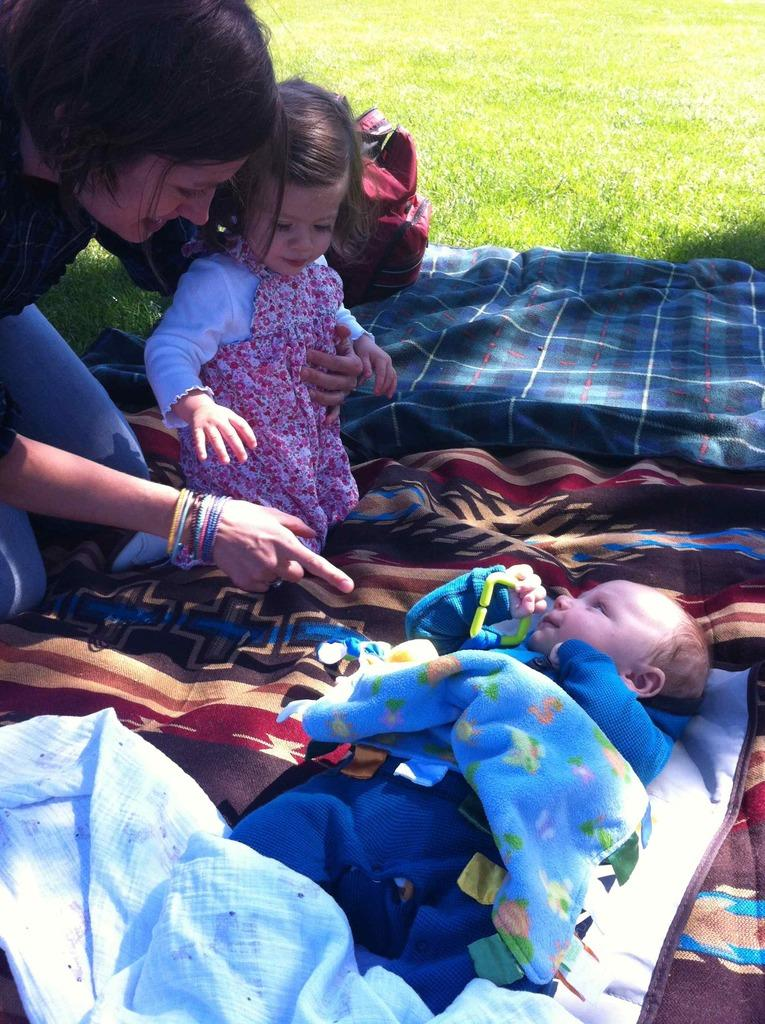What is the baby doing in the image? The baby is lying on a blanket in the image. Who else is present in the image besides the baby? There is a woman and a small girl in the image. How is the small girl positioned in relation to the woman? The small girl is sitting on the woman's knees. What can be seen in the background of the image? There is grass visible in the image. What object can be seen in the image that might be used for carrying items? There is a bag in the image. What idea does the deer have while sitting on the grass in the image? There is no deer present in the image, so it is not possible to answer that question. 